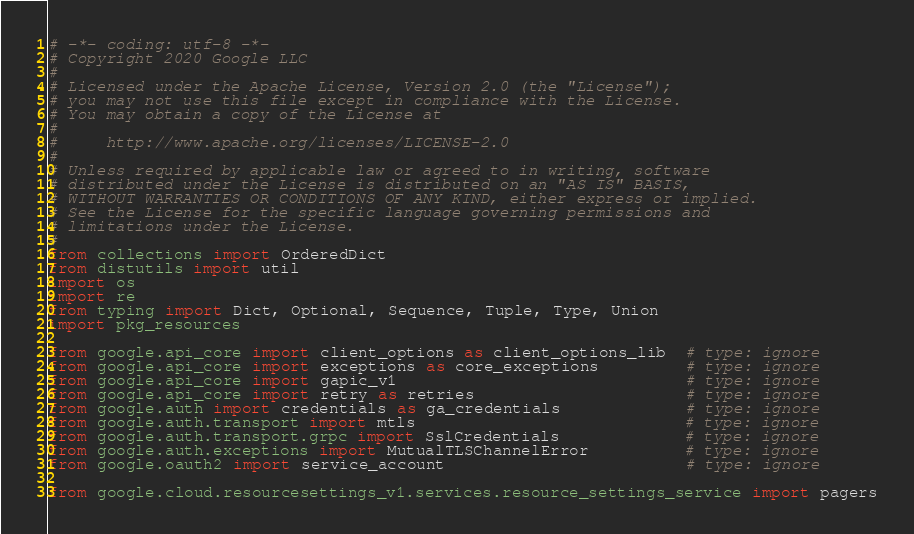Convert code to text. <code><loc_0><loc_0><loc_500><loc_500><_Python_># -*- coding: utf-8 -*-
# Copyright 2020 Google LLC
#
# Licensed under the Apache License, Version 2.0 (the "License");
# you may not use this file except in compliance with the License.
# You may obtain a copy of the License at
#
#     http://www.apache.org/licenses/LICENSE-2.0
#
# Unless required by applicable law or agreed to in writing, software
# distributed under the License is distributed on an "AS IS" BASIS,
# WITHOUT WARRANTIES OR CONDITIONS OF ANY KIND, either express or implied.
# See the License for the specific language governing permissions and
# limitations under the License.
#
from collections import OrderedDict
from distutils import util
import os
import re
from typing import Dict, Optional, Sequence, Tuple, Type, Union
import pkg_resources

from google.api_core import client_options as client_options_lib  # type: ignore
from google.api_core import exceptions as core_exceptions         # type: ignore
from google.api_core import gapic_v1                              # type: ignore
from google.api_core import retry as retries                      # type: ignore
from google.auth import credentials as ga_credentials             # type: ignore
from google.auth.transport import mtls                            # type: ignore
from google.auth.transport.grpc import SslCredentials             # type: ignore
from google.auth.exceptions import MutualTLSChannelError          # type: ignore
from google.oauth2 import service_account                         # type: ignore

from google.cloud.resourcesettings_v1.services.resource_settings_service import pagers</code> 